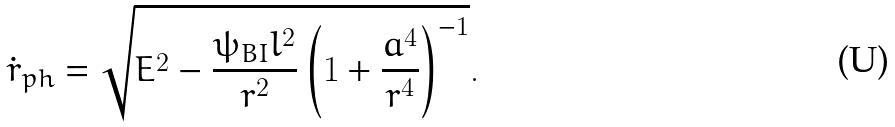<formula> <loc_0><loc_0><loc_500><loc_500>\dot { r } _ { p h } = \sqrt { E ^ { 2 } - \frac { \psi _ { B I } l ^ { 2 } } { r ^ { 2 } } \left ( 1 + \frac { a ^ { 4 } } { r ^ { 4 } } \right ) ^ { - 1 } } .</formula> 